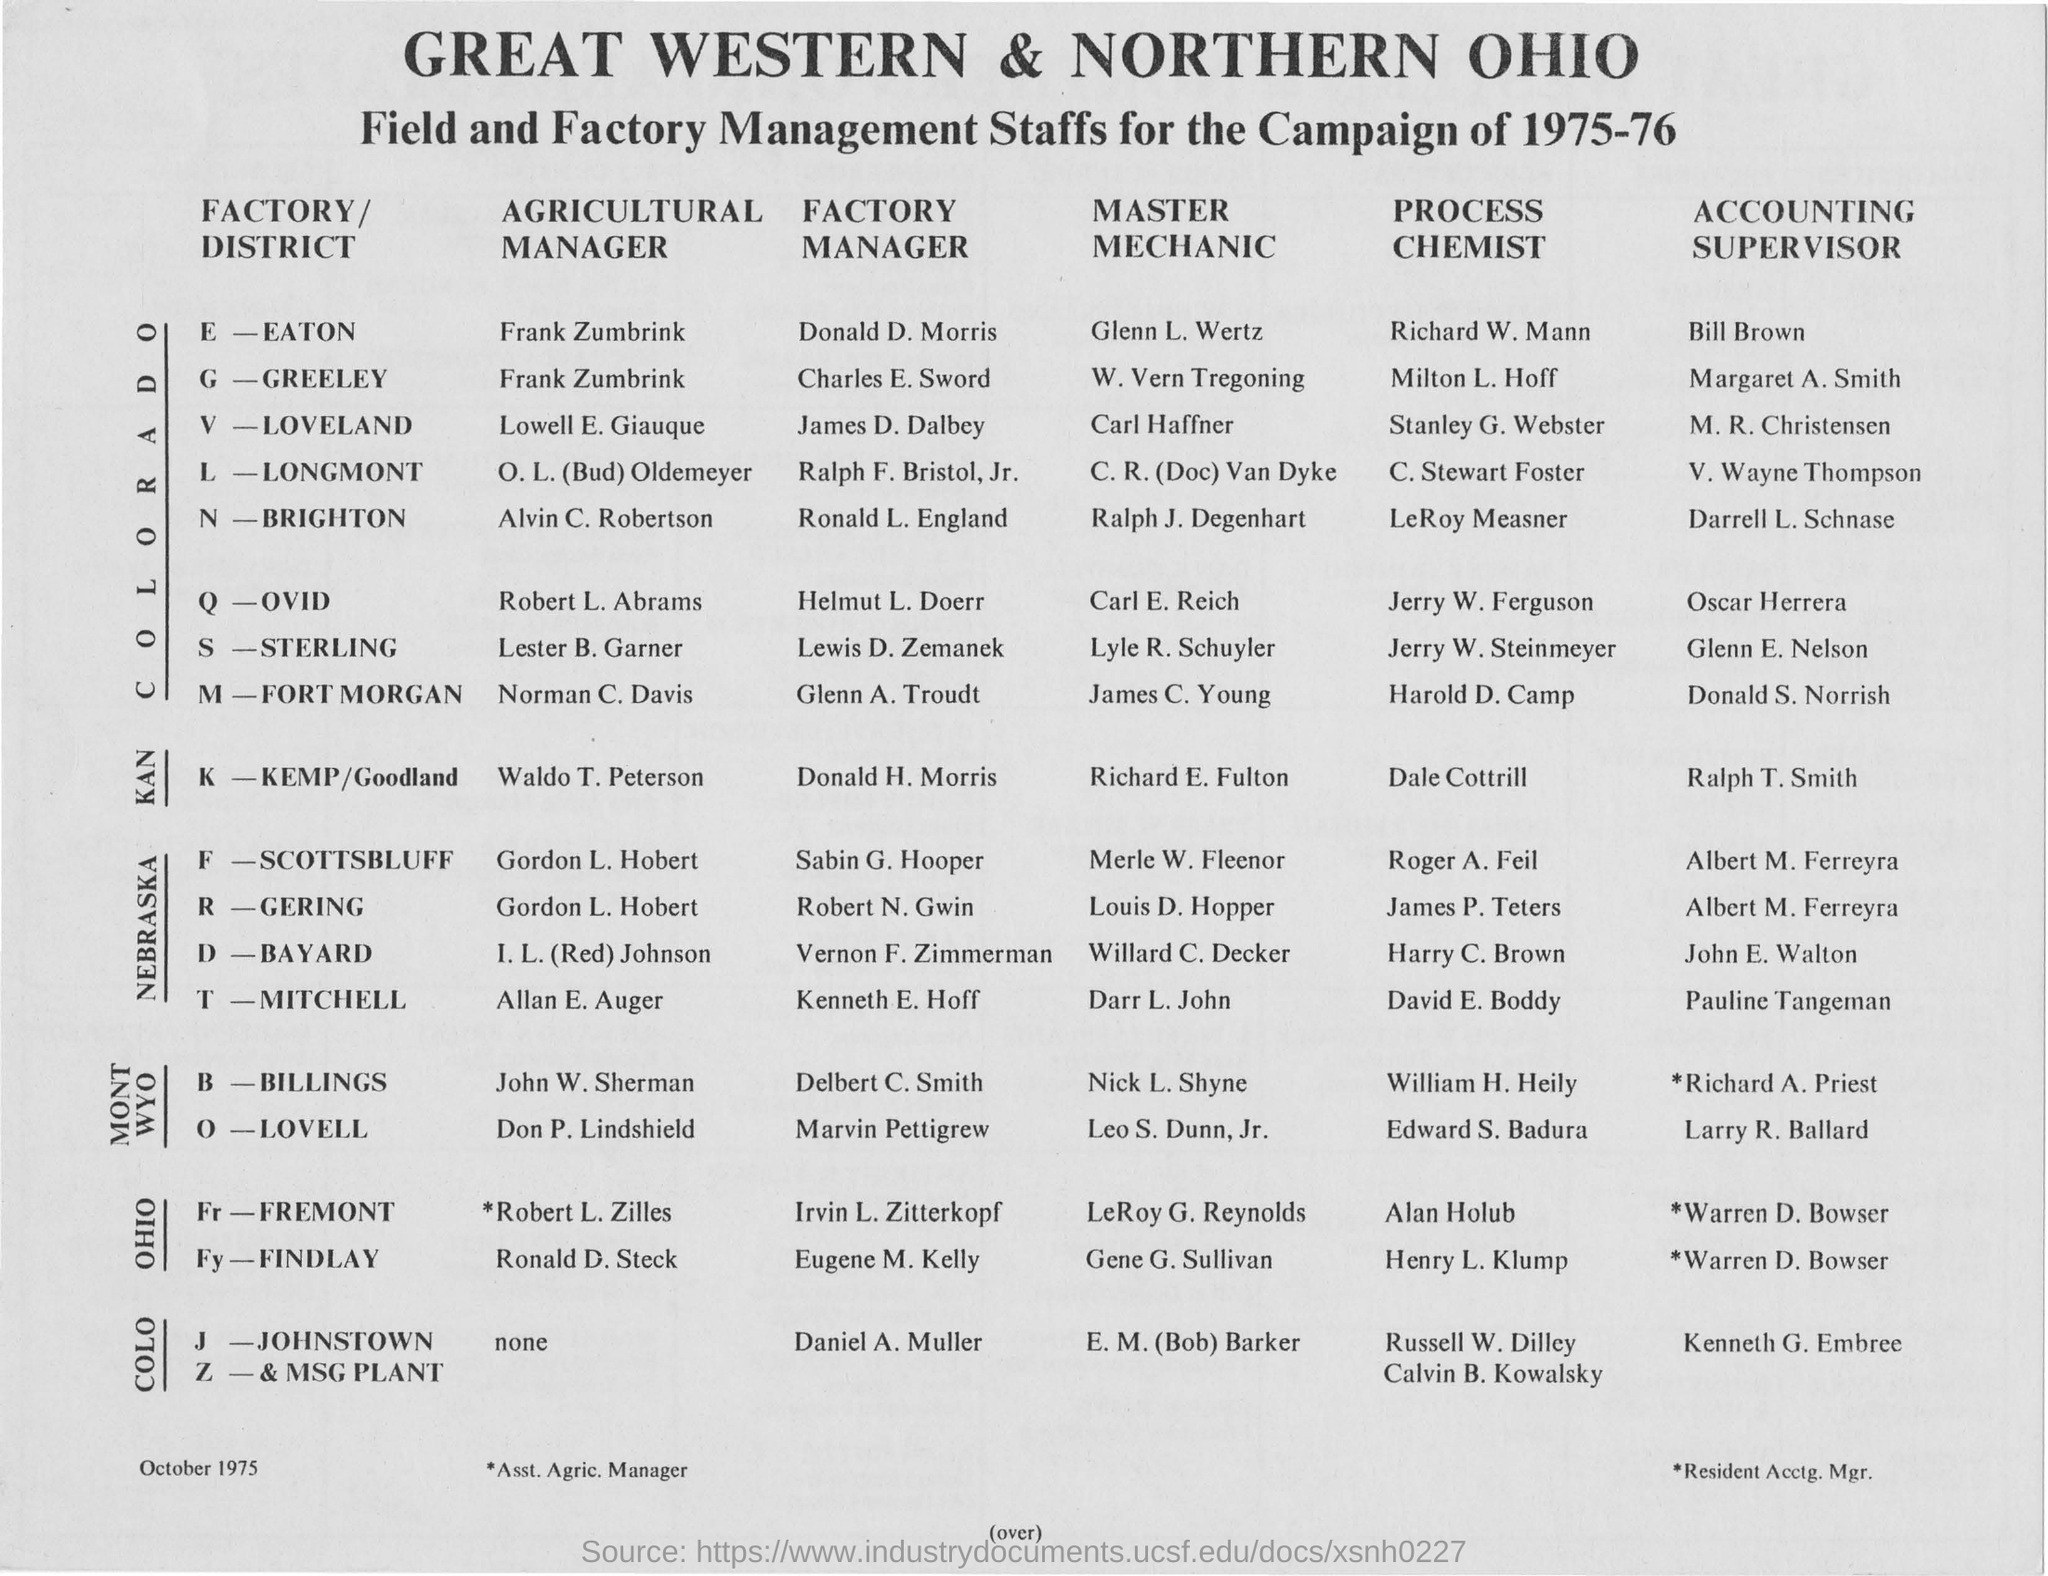What is the title of the document ?
Offer a very short reply. GREAT WESTERN & NORTHERN OHIO Field and Factory Management Staffs for the Campaign of 1975-76. What is the year mentioned in the top of the document ?
Offer a very short reply. 1975-76. Who is the Factory Manager of E-EATON?
Provide a succinct answer. Donald D. Morris. Who is the Agricultural Manager of the  N-BRIGHTON ?
Provide a succinct answer. Alvin C. Robertson. Who is the Master of Mechanic of the Q-OVID ?
Your response must be concise. Carl E. Reich. Who is the Accounting Supervisor of the S-STERLING ?
Your answer should be compact. Glenn E. Nelson. 